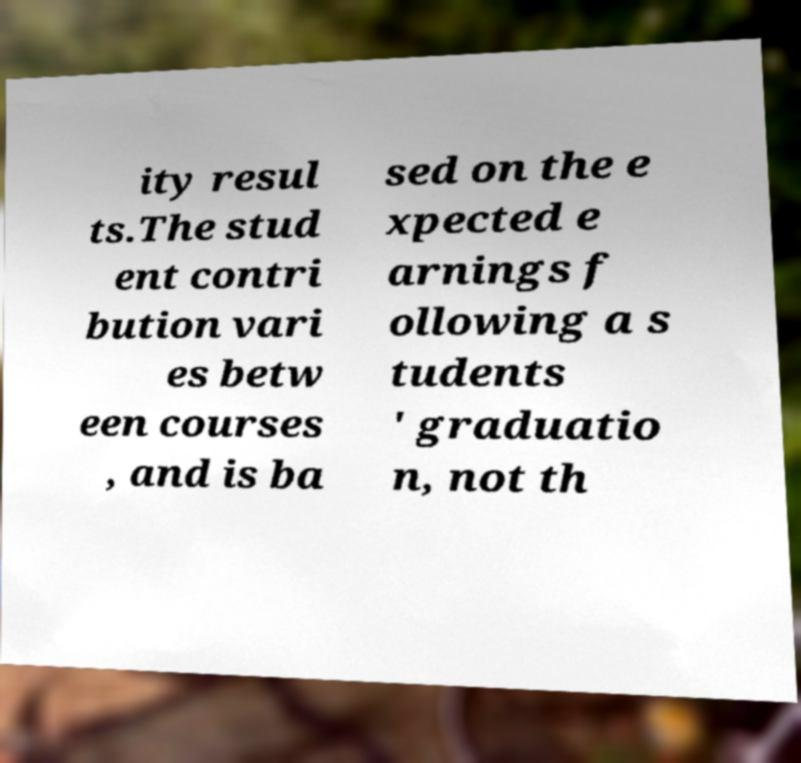For documentation purposes, I need the text within this image transcribed. Could you provide that? ity resul ts.The stud ent contri bution vari es betw een courses , and is ba sed on the e xpected e arnings f ollowing a s tudents ' graduatio n, not th 